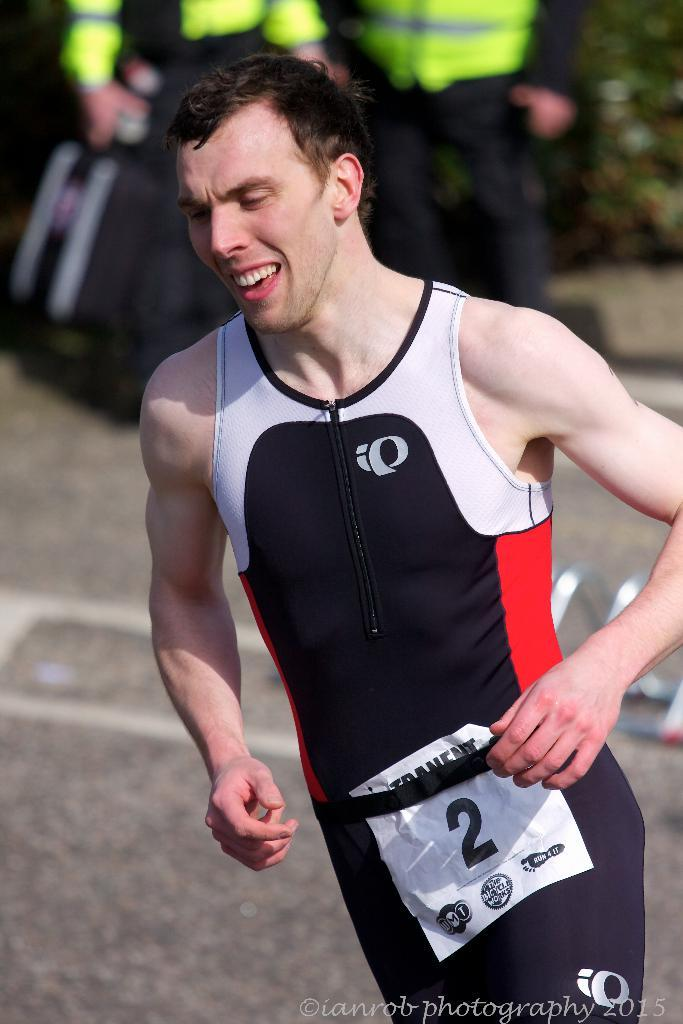<image>
Relay a brief, clear account of the picture shown. A man in a red, blue and white running uniform with a printed number 2 on a paper around his waist. 